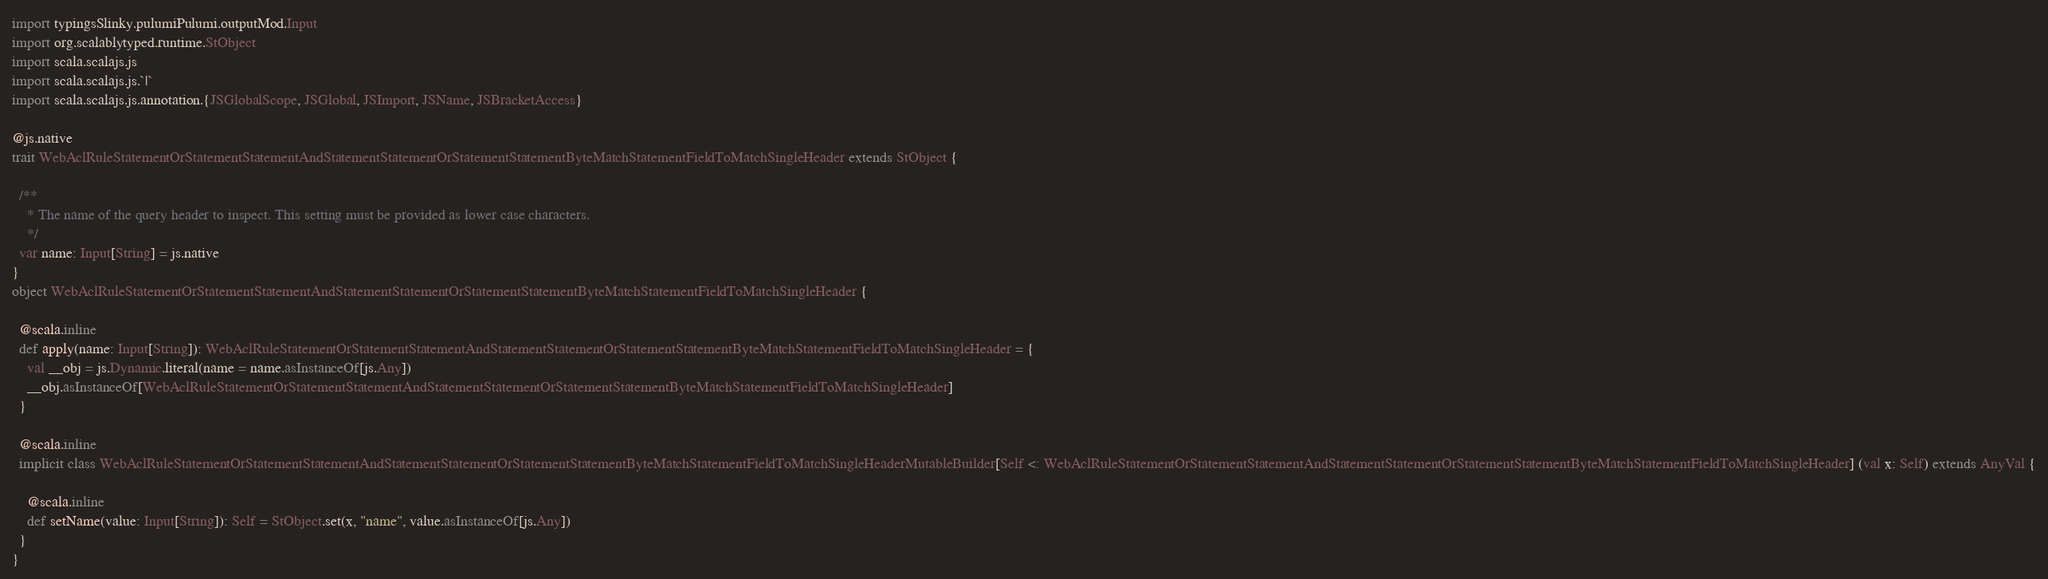<code> <loc_0><loc_0><loc_500><loc_500><_Scala_>import typingsSlinky.pulumiPulumi.outputMod.Input
import org.scalablytyped.runtime.StObject
import scala.scalajs.js
import scala.scalajs.js.`|`
import scala.scalajs.js.annotation.{JSGlobalScope, JSGlobal, JSImport, JSName, JSBracketAccess}

@js.native
trait WebAclRuleStatementOrStatementStatementAndStatementStatementOrStatementStatementByteMatchStatementFieldToMatchSingleHeader extends StObject {
  
  /**
    * The name of the query header to inspect. This setting must be provided as lower case characters.
    */
  var name: Input[String] = js.native
}
object WebAclRuleStatementOrStatementStatementAndStatementStatementOrStatementStatementByteMatchStatementFieldToMatchSingleHeader {
  
  @scala.inline
  def apply(name: Input[String]): WebAclRuleStatementOrStatementStatementAndStatementStatementOrStatementStatementByteMatchStatementFieldToMatchSingleHeader = {
    val __obj = js.Dynamic.literal(name = name.asInstanceOf[js.Any])
    __obj.asInstanceOf[WebAclRuleStatementOrStatementStatementAndStatementStatementOrStatementStatementByteMatchStatementFieldToMatchSingleHeader]
  }
  
  @scala.inline
  implicit class WebAclRuleStatementOrStatementStatementAndStatementStatementOrStatementStatementByteMatchStatementFieldToMatchSingleHeaderMutableBuilder[Self <: WebAclRuleStatementOrStatementStatementAndStatementStatementOrStatementStatementByteMatchStatementFieldToMatchSingleHeader] (val x: Self) extends AnyVal {
    
    @scala.inline
    def setName(value: Input[String]): Self = StObject.set(x, "name", value.asInstanceOf[js.Any])
  }
}
</code> 